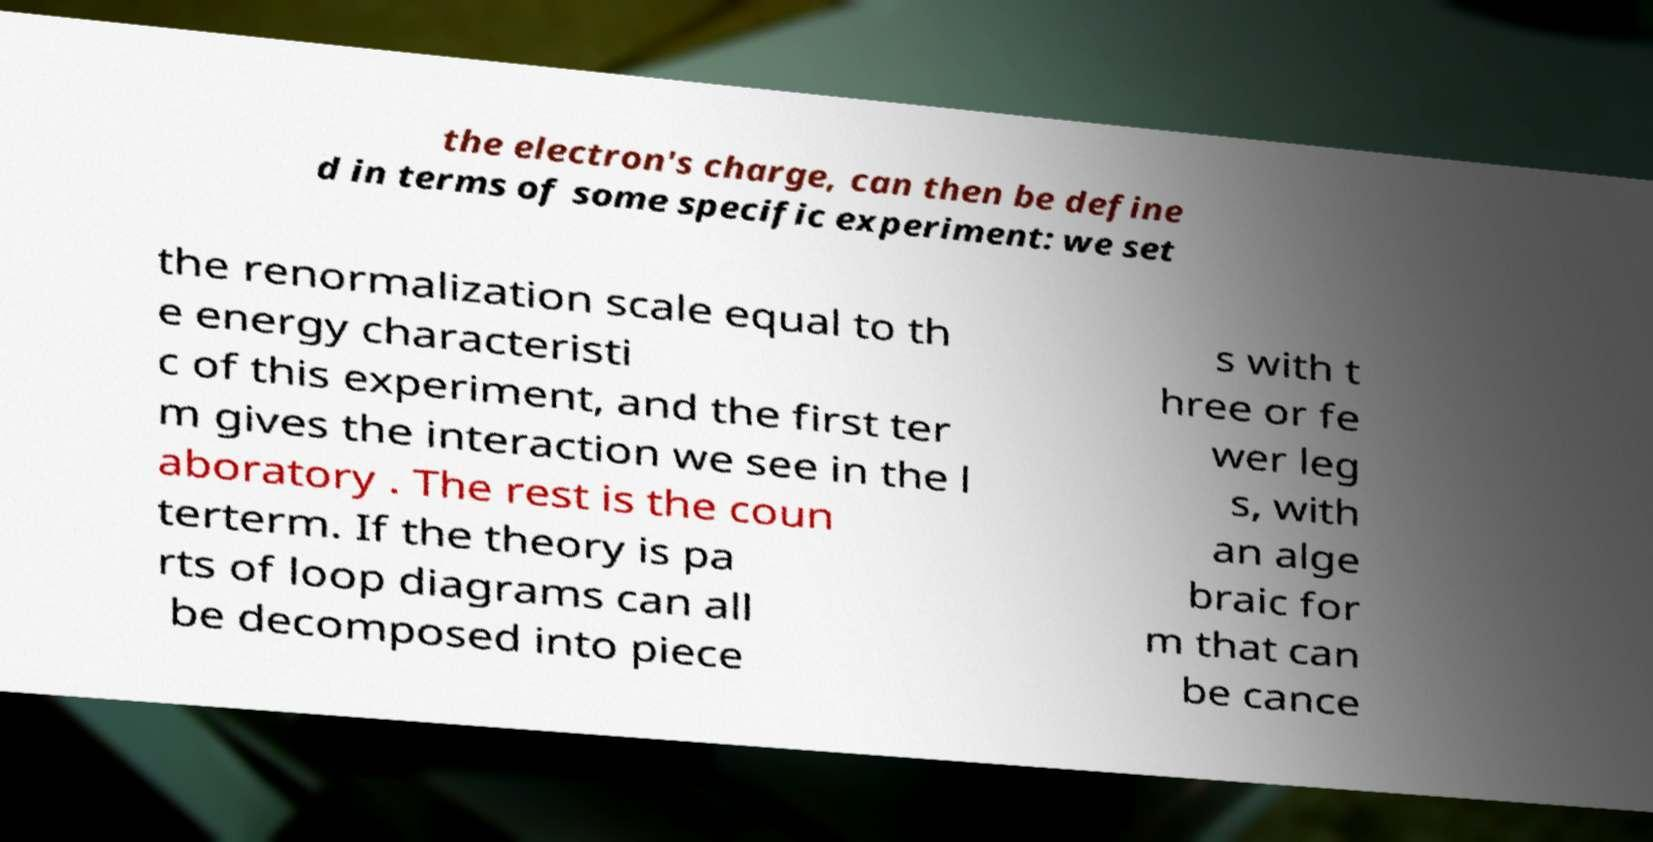What messages or text are displayed in this image? I need them in a readable, typed format. the electron's charge, can then be define d in terms of some specific experiment: we set the renormalization scale equal to th e energy characteristi c of this experiment, and the first ter m gives the interaction we see in the l aboratory . The rest is the coun terterm. If the theory is pa rts of loop diagrams can all be decomposed into piece s with t hree or fe wer leg s, with an alge braic for m that can be cance 